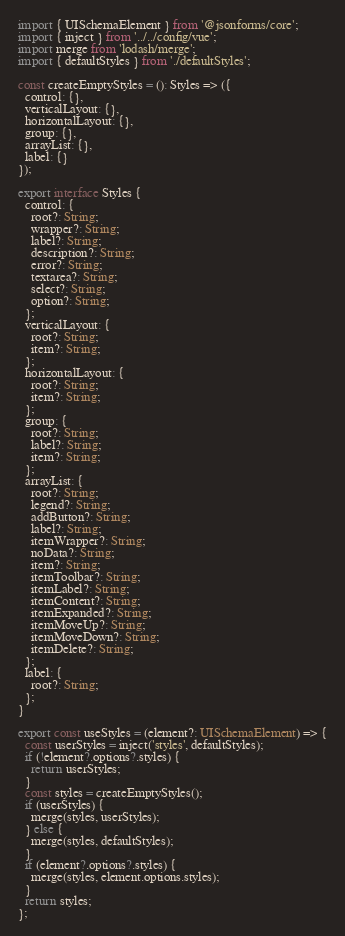Convert code to text. <code><loc_0><loc_0><loc_500><loc_500><_TypeScript_>import { UISchemaElement } from '@jsonforms/core';
import { inject } from '../../config/vue';
import merge from 'lodash/merge';
import { defaultStyles } from './defaultStyles';

const createEmptyStyles = (): Styles => ({
  control: {},
  verticalLayout: {},
  horizontalLayout: {},
  group: {},
  arrayList: {},
  label: {}
});

export interface Styles {
  control: {
    root?: String;
    wrapper?: String;
    label?: String;
    description?: String;
    error?: String;
    textarea?: String;
    select?: String;
    option?: String;
  };
  verticalLayout: {
    root?: String;
    item?: String;
  };
  horizontalLayout: {
    root?: String;
    item?: String;
  };
  group: {
    root?: String;
    label?: String;
    item?: String;
  };
  arrayList: {
    root?: String;
    legend?: String;
    addButton?: String;
    label?: String;
    itemWrapper?: String;
    noData?: String;
    item?: String;
    itemToolbar?: String;
    itemLabel?: String;
    itemContent?: String;
    itemExpanded?: String;
    itemMoveUp?: String;
    itemMoveDown?: String;
    itemDelete?: String;
  };
  label: {
    root?: String;
  };
}

export const useStyles = (element?: UISchemaElement) => {
  const userStyles = inject('styles', defaultStyles);
  if (!element?.options?.styles) {
    return userStyles;
  }
  const styles = createEmptyStyles();
  if (userStyles) {
    merge(styles, userStyles);
  } else {
    merge(styles, defaultStyles);
  }
  if (element?.options?.styles) {
    merge(styles, element.options.styles);
  }
  return styles;
};
</code> 